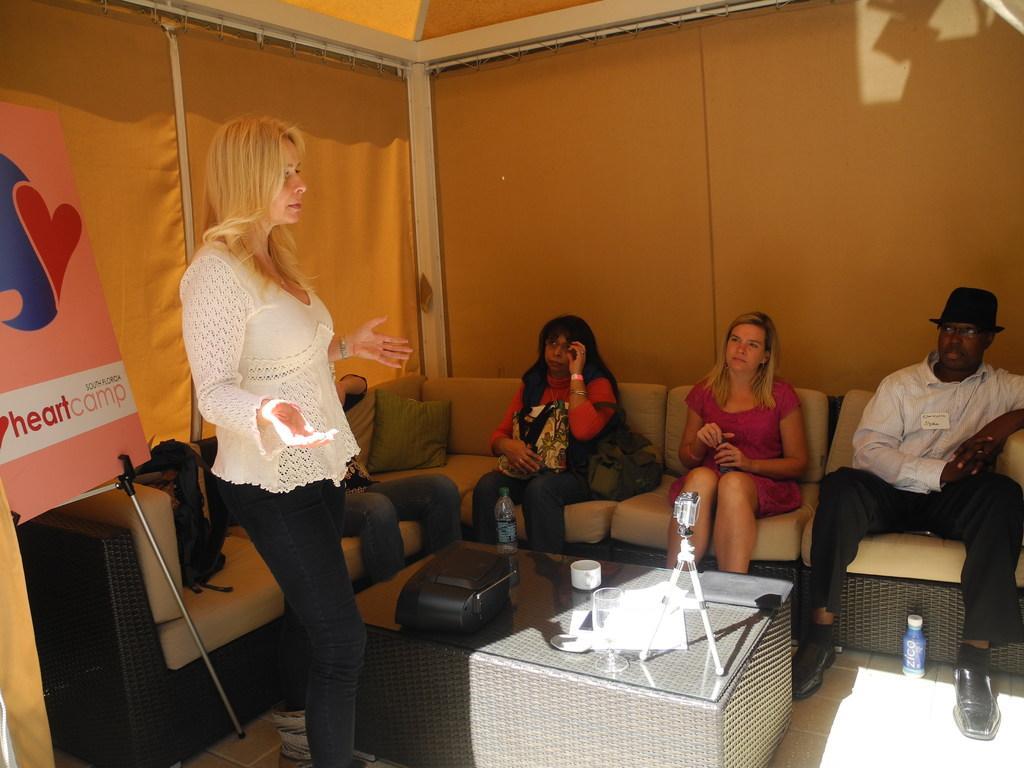Could you give a brief overview of what you see in this image? In the picture there is a woman stood at right side talking and in the background there is a sofa on which several people say,they all are under a tent. 